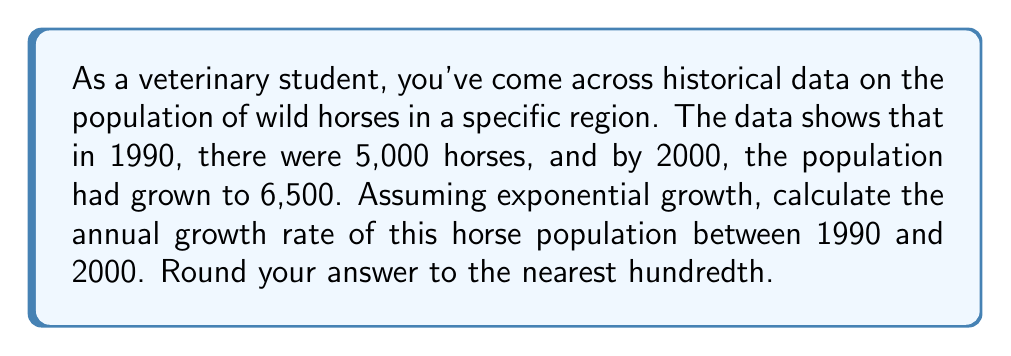Provide a solution to this math problem. To solve this problem, we'll use the exponential growth formula:

$$A = P(1 + r)^t$$

Where:
$A$ = Final amount (6,500 horses in 2000)
$P$ = Initial amount (5,000 horses in 1990)
$r$ = Annual growth rate (what we're solving for)
$t$ = Time period (10 years from 1990 to 2000)

Step 1: Plug the known values into the formula:
$$6500 = 5000(1 + r)^{10}$$

Step 2: Divide both sides by 5000:
$$\frac{6500}{5000} = (1 + r)^{10}$$

Step 3: Simplify:
$$1.3 = (1 + r)^{10}$$

Step 4: Take the 10th root of both sides:
$$\sqrt[10]{1.3} = 1 + r$$

Step 5: Subtract 1 from both sides:
$$\sqrt[10]{1.3} - 1 = r$$

Step 6: Calculate the result:
$$r \approx 0.0266$$

Step 7: Convert to a percentage and round to the nearest hundredth:
$$r \approx 2.66\%$$
Answer: 2.66% 